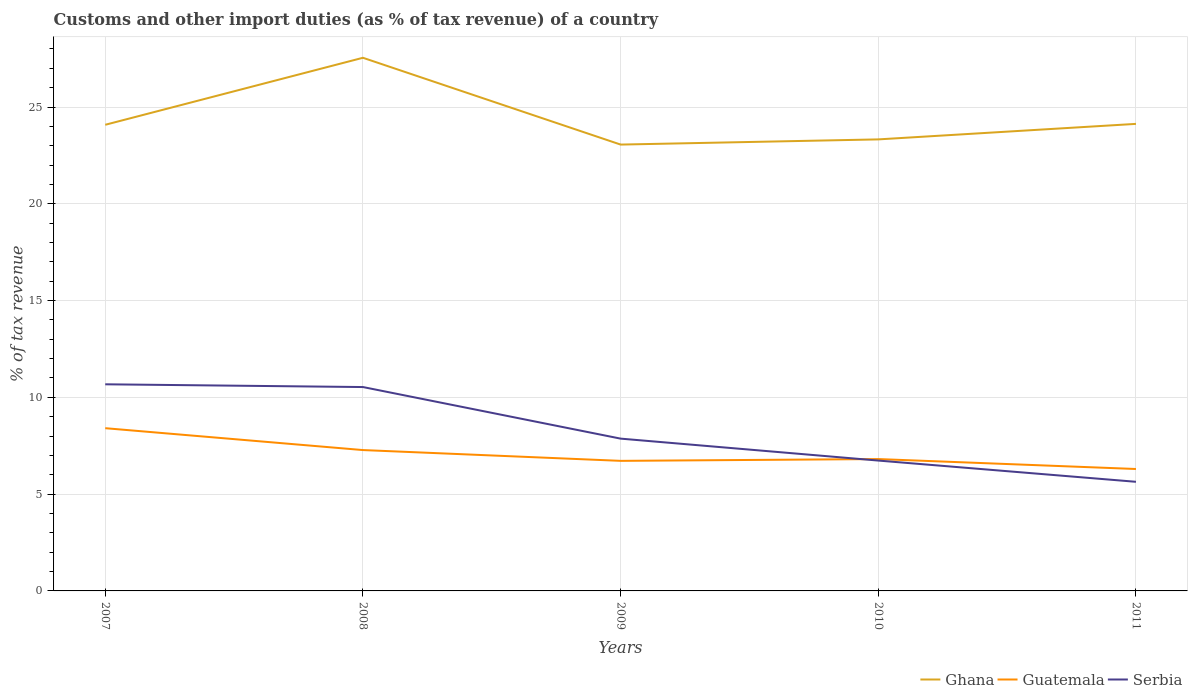Does the line corresponding to Guatemala intersect with the line corresponding to Ghana?
Give a very brief answer. No. Across all years, what is the maximum percentage of tax revenue from customs in Ghana?
Offer a very short reply. 23.06. What is the total percentage of tax revenue from customs in Guatemala in the graph?
Keep it short and to the point. 1.13. What is the difference between the highest and the second highest percentage of tax revenue from customs in Serbia?
Give a very brief answer. 5.04. How many lines are there?
Your response must be concise. 3. How many years are there in the graph?
Keep it short and to the point. 5. Does the graph contain grids?
Offer a very short reply. Yes. Where does the legend appear in the graph?
Make the answer very short. Bottom right. What is the title of the graph?
Keep it short and to the point. Customs and other import duties (as % of tax revenue) of a country. What is the label or title of the Y-axis?
Offer a very short reply. % of tax revenue. What is the % of tax revenue of Ghana in 2007?
Offer a very short reply. 24.08. What is the % of tax revenue of Guatemala in 2007?
Provide a succinct answer. 8.41. What is the % of tax revenue of Serbia in 2007?
Your answer should be very brief. 10.67. What is the % of tax revenue in Ghana in 2008?
Your answer should be very brief. 27.54. What is the % of tax revenue in Guatemala in 2008?
Offer a very short reply. 7.28. What is the % of tax revenue of Serbia in 2008?
Provide a succinct answer. 10.53. What is the % of tax revenue of Ghana in 2009?
Provide a succinct answer. 23.06. What is the % of tax revenue in Guatemala in 2009?
Your response must be concise. 6.72. What is the % of tax revenue of Serbia in 2009?
Keep it short and to the point. 7.87. What is the % of tax revenue in Ghana in 2010?
Ensure brevity in your answer.  23.33. What is the % of tax revenue in Guatemala in 2010?
Make the answer very short. 6.81. What is the % of tax revenue of Serbia in 2010?
Offer a terse response. 6.73. What is the % of tax revenue in Ghana in 2011?
Provide a short and direct response. 24.13. What is the % of tax revenue of Guatemala in 2011?
Your response must be concise. 6.3. What is the % of tax revenue of Serbia in 2011?
Your response must be concise. 5.64. Across all years, what is the maximum % of tax revenue of Ghana?
Keep it short and to the point. 27.54. Across all years, what is the maximum % of tax revenue of Guatemala?
Provide a short and direct response. 8.41. Across all years, what is the maximum % of tax revenue in Serbia?
Offer a very short reply. 10.67. Across all years, what is the minimum % of tax revenue in Ghana?
Your answer should be compact. 23.06. Across all years, what is the minimum % of tax revenue of Guatemala?
Offer a terse response. 6.3. Across all years, what is the minimum % of tax revenue of Serbia?
Offer a very short reply. 5.64. What is the total % of tax revenue of Ghana in the graph?
Make the answer very short. 122.14. What is the total % of tax revenue of Guatemala in the graph?
Your answer should be compact. 35.51. What is the total % of tax revenue in Serbia in the graph?
Offer a terse response. 41.45. What is the difference between the % of tax revenue of Ghana in 2007 and that in 2008?
Ensure brevity in your answer.  -3.46. What is the difference between the % of tax revenue of Guatemala in 2007 and that in 2008?
Make the answer very short. 1.13. What is the difference between the % of tax revenue in Serbia in 2007 and that in 2008?
Keep it short and to the point. 0.14. What is the difference between the % of tax revenue in Ghana in 2007 and that in 2009?
Ensure brevity in your answer.  1.02. What is the difference between the % of tax revenue in Guatemala in 2007 and that in 2009?
Ensure brevity in your answer.  1.69. What is the difference between the % of tax revenue in Serbia in 2007 and that in 2009?
Your answer should be compact. 2.81. What is the difference between the % of tax revenue of Ghana in 2007 and that in 2010?
Ensure brevity in your answer.  0.76. What is the difference between the % of tax revenue of Guatemala in 2007 and that in 2010?
Your answer should be compact. 1.6. What is the difference between the % of tax revenue in Serbia in 2007 and that in 2010?
Your answer should be compact. 3.94. What is the difference between the % of tax revenue of Ghana in 2007 and that in 2011?
Your response must be concise. -0.05. What is the difference between the % of tax revenue in Guatemala in 2007 and that in 2011?
Your answer should be compact. 2.11. What is the difference between the % of tax revenue of Serbia in 2007 and that in 2011?
Provide a short and direct response. 5.04. What is the difference between the % of tax revenue of Ghana in 2008 and that in 2009?
Your answer should be compact. 4.48. What is the difference between the % of tax revenue of Guatemala in 2008 and that in 2009?
Make the answer very short. 0.56. What is the difference between the % of tax revenue in Serbia in 2008 and that in 2009?
Offer a terse response. 2.66. What is the difference between the % of tax revenue of Ghana in 2008 and that in 2010?
Your answer should be very brief. 4.22. What is the difference between the % of tax revenue of Guatemala in 2008 and that in 2010?
Offer a very short reply. 0.46. What is the difference between the % of tax revenue in Serbia in 2008 and that in 2010?
Ensure brevity in your answer.  3.8. What is the difference between the % of tax revenue in Ghana in 2008 and that in 2011?
Your response must be concise. 3.41. What is the difference between the % of tax revenue in Guatemala in 2008 and that in 2011?
Give a very brief answer. 0.98. What is the difference between the % of tax revenue in Serbia in 2008 and that in 2011?
Your answer should be compact. 4.9. What is the difference between the % of tax revenue in Ghana in 2009 and that in 2010?
Ensure brevity in your answer.  -0.27. What is the difference between the % of tax revenue of Guatemala in 2009 and that in 2010?
Your answer should be very brief. -0.09. What is the difference between the % of tax revenue of Serbia in 2009 and that in 2010?
Your answer should be compact. 1.13. What is the difference between the % of tax revenue in Ghana in 2009 and that in 2011?
Your answer should be very brief. -1.07. What is the difference between the % of tax revenue of Guatemala in 2009 and that in 2011?
Your response must be concise. 0.42. What is the difference between the % of tax revenue of Serbia in 2009 and that in 2011?
Offer a terse response. 2.23. What is the difference between the % of tax revenue in Ghana in 2010 and that in 2011?
Make the answer very short. -0.8. What is the difference between the % of tax revenue of Guatemala in 2010 and that in 2011?
Provide a short and direct response. 0.51. What is the difference between the % of tax revenue of Serbia in 2010 and that in 2011?
Give a very brief answer. 1.1. What is the difference between the % of tax revenue of Ghana in 2007 and the % of tax revenue of Guatemala in 2008?
Make the answer very short. 16.8. What is the difference between the % of tax revenue of Ghana in 2007 and the % of tax revenue of Serbia in 2008?
Offer a terse response. 13.55. What is the difference between the % of tax revenue in Guatemala in 2007 and the % of tax revenue in Serbia in 2008?
Keep it short and to the point. -2.13. What is the difference between the % of tax revenue in Ghana in 2007 and the % of tax revenue in Guatemala in 2009?
Give a very brief answer. 17.36. What is the difference between the % of tax revenue in Ghana in 2007 and the % of tax revenue in Serbia in 2009?
Your response must be concise. 16.21. What is the difference between the % of tax revenue in Guatemala in 2007 and the % of tax revenue in Serbia in 2009?
Your answer should be compact. 0.54. What is the difference between the % of tax revenue of Ghana in 2007 and the % of tax revenue of Guatemala in 2010?
Offer a very short reply. 17.27. What is the difference between the % of tax revenue in Ghana in 2007 and the % of tax revenue in Serbia in 2010?
Provide a succinct answer. 17.35. What is the difference between the % of tax revenue of Guatemala in 2007 and the % of tax revenue of Serbia in 2010?
Provide a succinct answer. 1.67. What is the difference between the % of tax revenue in Ghana in 2007 and the % of tax revenue in Guatemala in 2011?
Ensure brevity in your answer.  17.78. What is the difference between the % of tax revenue in Ghana in 2007 and the % of tax revenue in Serbia in 2011?
Give a very brief answer. 18.44. What is the difference between the % of tax revenue of Guatemala in 2007 and the % of tax revenue of Serbia in 2011?
Keep it short and to the point. 2.77. What is the difference between the % of tax revenue of Ghana in 2008 and the % of tax revenue of Guatemala in 2009?
Offer a very short reply. 20.82. What is the difference between the % of tax revenue in Ghana in 2008 and the % of tax revenue in Serbia in 2009?
Provide a short and direct response. 19.68. What is the difference between the % of tax revenue of Guatemala in 2008 and the % of tax revenue of Serbia in 2009?
Give a very brief answer. -0.59. What is the difference between the % of tax revenue of Ghana in 2008 and the % of tax revenue of Guatemala in 2010?
Provide a succinct answer. 20.73. What is the difference between the % of tax revenue of Ghana in 2008 and the % of tax revenue of Serbia in 2010?
Offer a terse response. 20.81. What is the difference between the % of tax revenue of Guatemala in 2008 and the % of tax revenue of Serbia in 2010?
Keep it short and to the point. 0.54. What is the difference between the % of tax revenue in Ghana in 2008 and the % of tax revenue in Guatemala in 2011?
Offer a very short reply. 21.24. What is the difference between the % of tax revenue in Ghana in 2008 and the % of tax revenue in Serbia in 2011?
Your answer should be very brief. 21.91. What is the difference between the % of tax revenue of Guatemala in 2008 and the % of tax revenue of Serbia in 2011?
Your answer should be compact. 1.64. What is the difference between the % of tax revenue of Ghana in 2009 and the % of tax revenue of Guatemala in 2010?
Offer a terse response. 16.25. What is the difference between the % of tax revenue in Ghana in 2009 and the % of tax revenue in Serbia in 2010?
Keep it short and to the point. 16.32. What is the difference between the % of tax revenue of Guatemala in 2009 and the % of tax revenue of Serbia in 2010?
Your response must be concise. -0.02. What is the difference between the % of tax revenue in Ghana in 2009 and the % of tax revenue in Guatemala in 2011?
Provide a succinct answer. 16.76. What is the difference between the % of tax revenue in Ghana in 2009 and the % of tax revenue in Serbia in 2011?
Your answer should be very brief. 17.42. What is the difference between the % of tax revenue in Guatemala in 2009 and the % of tax revenue in Serbia in 2011?
Make the answer very short. 1.08. What is the difference between the % of tax revenue of Ghana in 2010 and the % of tax revenue of Guatemala in 2011?
Your response must be concise. 17.03. What is the difference between the % of tax revenue in Ghana in 2010 and the % of tax revenue in Serbia in 2011?
Offer a terse response. 17.69. What is the difference between the % of tax revenue of Guatemala in 2010 and the % of tax revenue of Serbia in 2011?
Your answer should be compact. 1.17. What is the average % of tax revenue of Ghana per year?
Offer a very short reply. 24.43. What is the average % of tax revenue in Guatemala per year?
Your answer should be very brief. 7.1. What is the average % of tax revenue in Serbia per year?
Your answer should be compact. 8.29. In the year 2007, what is the difference between the % of tax revenue of Ghana and % of tax revenue of Guatemala?
Provide a short and direct response. 15.67. In the year 2007, what is the difference between the % of tax revenue of Ghana and % of tax revenue of Serbia?
Your answer should be very brief. 13.41. In the year 2007, what is the difference between the % of tax revenue of Guatemala and % of tax revenue of Serbia?
Offer a very short reply. -2.27. In the year 2008, what is the difference between the % of tax revenue of Ghana and % of tax revenue of Guatemala?
Provide a succinct answer. 20.27. In the year 2008, what is the difference between the % of tax revenue in Ghana and % of tax revenue in Serbia?
Offer a very short reply. 17.01. In the year 2008, what is the difference between the % of tax revenue in Guatemala and % of tax revenue in Serbia?
Offer a terse response. -3.26. In the year 2009, what is the difference between the % of tax revenue of Ghana and % of tax revenue of Guatemala?
Your response must be concise. 16.34. In the year 2009, what is the difference between the % of tax revenue in Ghana and % of tax revenue in Serbia?
Provide a short and direct response. 15.19. In the year 2009, what is the difference between the % of tax revenue of Guatemala and % of tax revenue of Serbia?
Your answer should be compact. -1.15. In the year 2010, what is the difference between the % of tax revenue in Ghana and % of tax revenue in Guatemala?
Your answer should be compact. 16.51. In the year 2010, what is the difference between the % of tax revenue of Ghana and % of tax revenue of Serbia?
Your answer should be very brief. 16.59. In the year 2010, what is the difference between the % of tax revenue of Guatemala and % of tax revenue of Serbia?
Offer a very short reply. 0.08. In the year 2011, what is the difference between the % of tax revenue of Ghana and % of tax revenue of Guatemala?
Provide a succinct answer. 17.83. In the year 2011, what is the difference between the % of tax revenue of Ghana and % of tax revenue of Serbia?
Offer a very short reply. 18.49. In the year 2011, what is the difference between the % of tax revenue of Guatemala and % of tax revenue of Serbia?
Offer a terse response. 0.66. What is the ratio of the % of tax revenue in Ghana in 2007 to that in 2008?
Your answer should be compact. 0.87. What is the ratio of the % of tax revenue in Guatemala in 2007 to that in 2008?
Your answer should be very brief. 1.16. What is the ratio of the % of tax revenue of Serbia in 2007 to that in 2008?
Keep it short and to the point. 1.01. What is the ratio of the % of tax revenue in Ghana in 2007 to that in 2009?
Provide a short and direct response. 1.04. What is the ratio of the % of tax revenue in Guatemala in 2007 to that in 2009?
Make the answer very short. 1.25. What is the ratio of the % of tax revenue in Serbia in 2007 to that in 2009?
Provide a short and direct response. 1.36. What is the ratio of the % of tax revenue in Ghana in 2007 to that in 2010?
Keep it short and to the point. 1.03. What is the ratio of the % of tax revenue in Guatemala in 2007 to that in 2010?
Give a very brief answer. 1.23. What is the ratio of the % of tax revenue in Serbia in 2007 to that in 2010?
Keep it short and to the point. 1.58. What is the ratio of the % of tax revenue of Guatemala in 2007 to that in 2011?
Provide a succinct answer. 1.33. What is the ratio of the % of tax revenue in Serbia in 2007 to that in 2011?
Provide a succinct answer. 1.89. What is the ratio of the % of tax revenue of Ghana in 2008 to that in 2009?
Make the answer very short. 1.19. What is the ratio of the % of tax revenue of Guatemala in 2008 to that in 2009?
Give a very brief answer. 1.08. What is the ratio of the % of tax revenue of Serbia in 2008 to that in 2009?
Offer a terse response. 1.34. What is the ratio of the % of tax revenue in Ghana in 2008 to that in 2010?
Your answer should be very brief. 1.18. What is the ratio of the % of tax revenue of Guatemala in 2008 to that in 2010?
Ensure brevity in your answer.  1.07. What is the ratio of the % of tax revenue in Serbia in 2008 to that in 2010?
Provide a succinct answer. 1.56. What is the ratio of the % of tax revenue in Ghana in 2008 to that in 2011?
Offer a very short reply. 1.14. What is the ratio of the % of tax revenue of Guatemala in 2008 to that in 2011?
Offer a terse response. 1.16. What is the ratio of the % of tax revenue of Serbia in 2008 to that in 2011?
Provide a succinct answer. 1.87. What is the ratio of the % of tax revenue in Guatemala in 2009 to that in 2010?
Your answer should be compact. 0.99. What is the ratio of the % of tax revenue of Serbia in 2009 to that in 2010?
Keep it short and to the point. 1.17. What is the ratio of the % of tax revenue in Ghana in 2009 to that in 2011?
Ensure brevity in your answer.  0.96. What is the ratio of the % of tax revenue of Guatemala in 2009 to that in 2011?
Offer a very short reply. 1.07. What is the ratio of the % of tax revenue of Serbia in 2009 to that in 2011?
Make the answer very short. 1.4. What is the ratio of the % of tax revenue in Ghana in 2010 to that in 2011?
Offer a terse response. 0.97. What is the ratio of the % of tax revenue in Guatemala in 2010 to that in 2011?
Offer a terse response. 1.08. What is the ratio of the % of tax revenue in Serbia in 2010 to that in 2011?
Provide a succinct answer. 1.19. What is the difference between the highest and the second highest % of tax revenue of Ghana?
Keep it short and to the point. 3.41. What is the difference between the highest and the second highest % of tax revenue of Guatemala?
Provide a short and direct response. 1.13. What is the difference between the highest and the second highest % of tax revenue of Serbia?
Offer a terse response. 0.14. What is the difference between the highest and the lowest % of tax revenue of Ghana?
Give a very brief answer. 4.48. What is the difference between the highest and the lowest % of tax revenue of Guatemala?
Provide a short and direct response. 2.11. What is the difference between the highest and the lowest % of tax revenue in Serbia?
Provide a succinct answer. 5.04. 